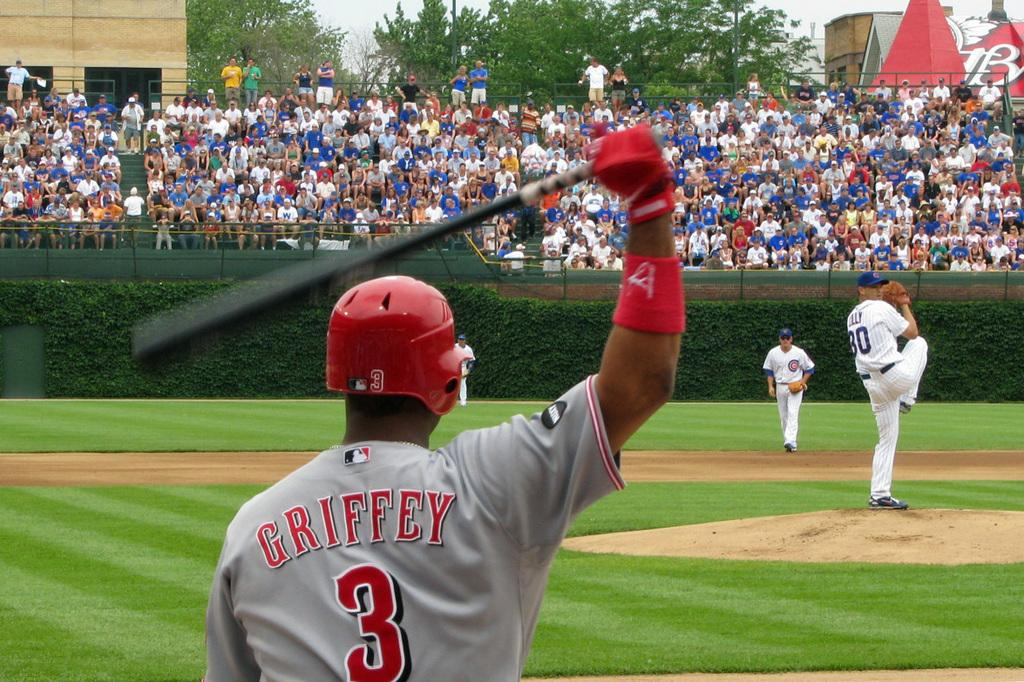<image>
Give a short and clear explanation of the subsequent image. The pitcher is posed to pitch the ball to player number 3. 